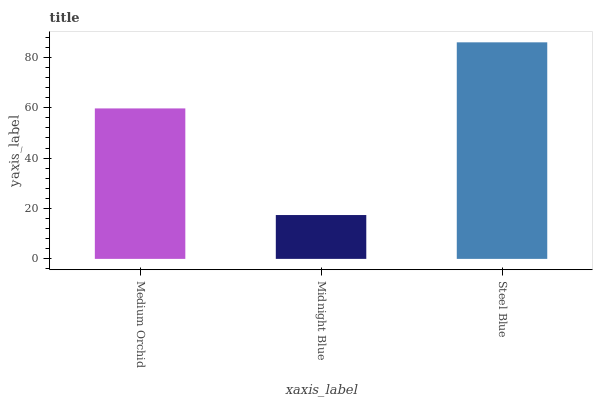Is Midnight Blue the minimum?
Answer yes or no. Yes. Is Steel Blue the maximum?
Answer yes or no. Yes. Is Steel Blue the minimum?
Answer yes or no. No. Is Midnight Blue the maximum?
Answer yes or no. No. Is Steel Blue greater than Midnight Blue?
Answer yes or no. Yes. Is Midnight Blue less than Steel Blue?
Answer yes or no. Yes. Is Midnight Blue greater than Steel Blue?
Answer yes or no. No. Is Steel Blue less than Midnight Blue?
Answer yes or no. No. Is Medium Orchid the high median?
Answer yes or no. Yes. Is Medium Orchid the low median?
Answer yes or no. Yes. Is Midnight Blue the high median?
Answer yes or no. No. Is Midnight Blue the low median?
Answer yes or no. No. 